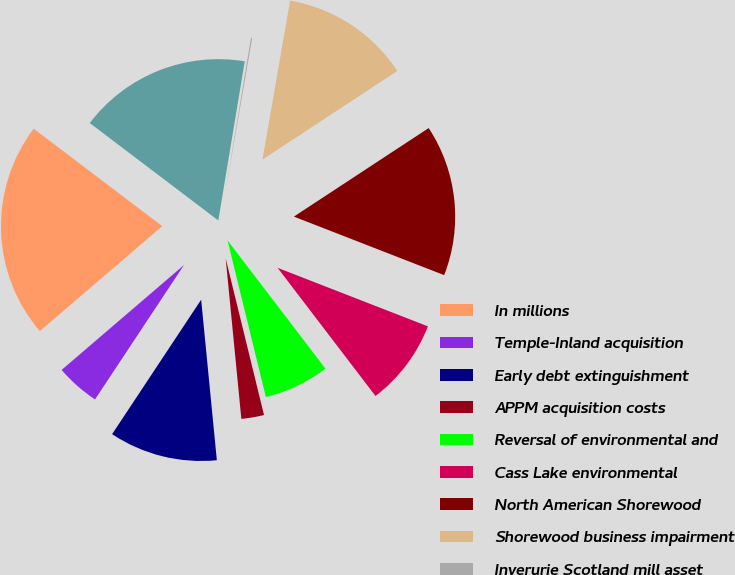Convert chart to OTSL. <chart><loc_0><loc_0><loc_500><loc_500><pie_chart><fcel>In millions<fcel>Temple-Inland acquisition<fcel>Early debt extinguishment<fcel>APPM acquisition costs<fcel>Reversal of environmental and<fcel>Cass Lake environmental<fcel>North American Shorewood<fcel>Shorewood business impairment<fcel>Inverurie Scotland mill asset<fcel>Total<nl><fcel>21.6%<fcel>4.41%<fcel>10.86%<fcel>2.27%<fcel>6.56%<fcel>8.71%<fcel>15.16%<fcel>13.01%<fcel>0.12%<fcel>17.3%<nl></chart> 